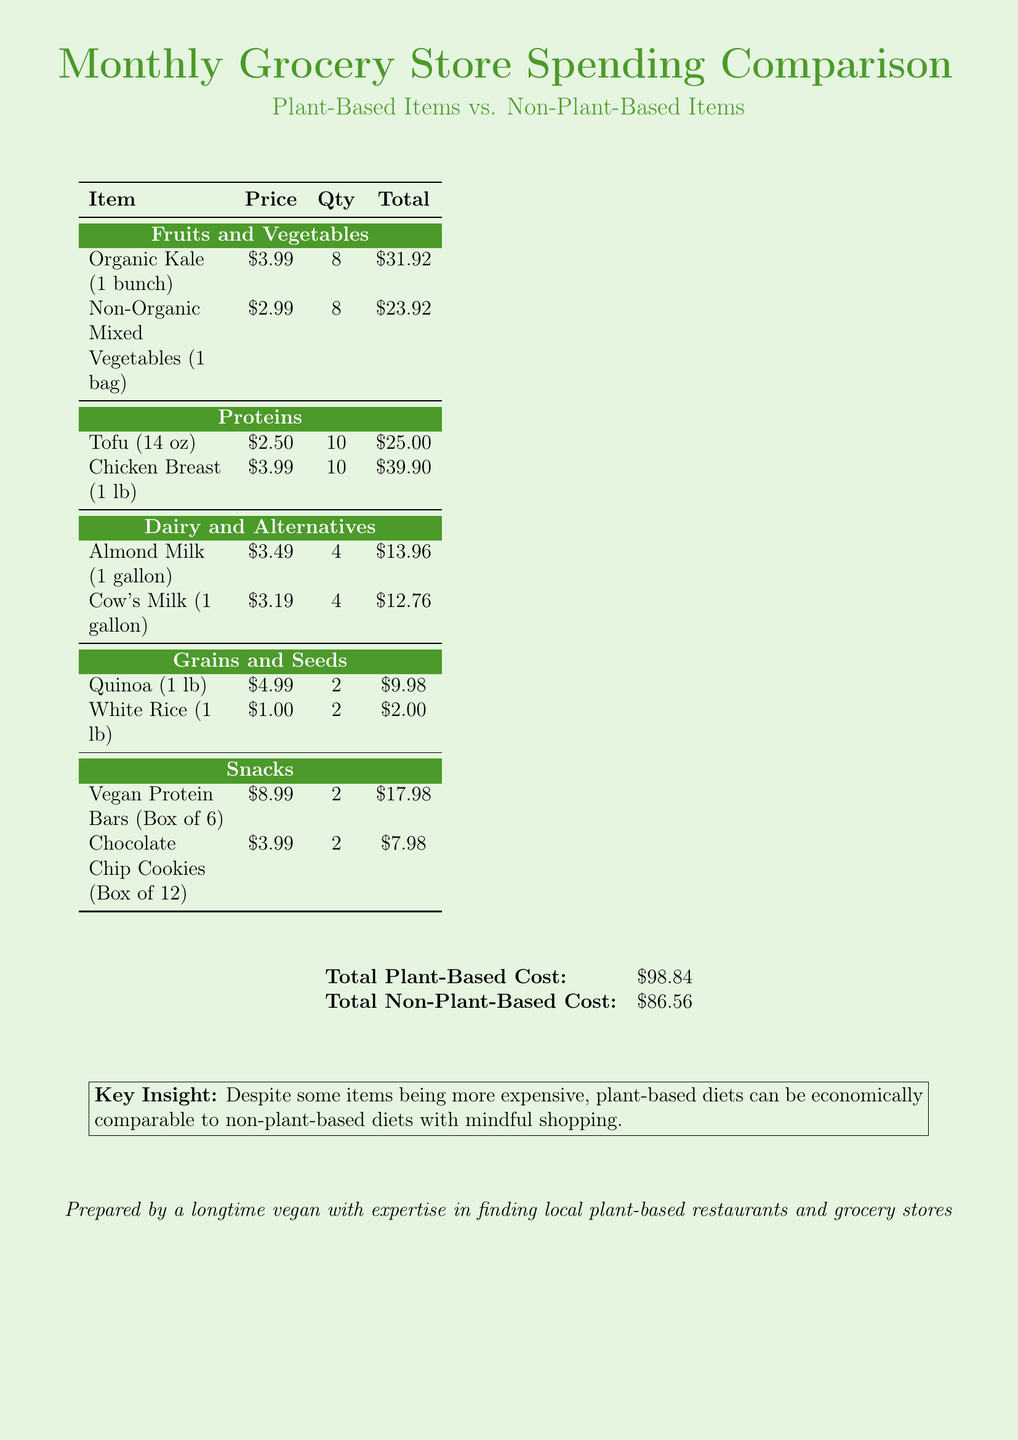What is the total cost of plant-based items? The total cost of plant-based items is stated at the bottom of the document.
Answer: $98.84 What is the total cost of non-plant-based items? The total cost of non-plant-based items is stated at the bottom of the document.
Answer: $86.56 Which plant-based protein item is listed? The document includes tofu as a plant-based protein item.
Answer: Tofu How many bags of non-organic mixed vegetables were purchased? The quantity of non-organic mixed vegetables is provided in the item row for that product.
Answer: 8 What is the price per gallon of almond milk? The price of almond milk is specified in the dairy and alternatives section.
Answer: $3.49 What is the total quantity of tofu purchased? The quantity of tofu is provided in the item row for that product in the document.
Answer: 10 Which type of non-plant-based milk is mentioned? The document lists cow's milk as the non-plant-based milk.
Answer: Cow's Milk How many boxes of vegan protein bars were bought? The quantity of vegan protein bars is provided in the snacks category of the table.
Answer: 2 What key insight is provided at the bottom of the scorecard? The key insight summarizes the main takeaway regarding plant-based diets in comparison to non-plant-based diets.
Answer: Despite some items being more expensive, plant-based diets can be economically comparable to non-plant-based diets with mindful shopping 